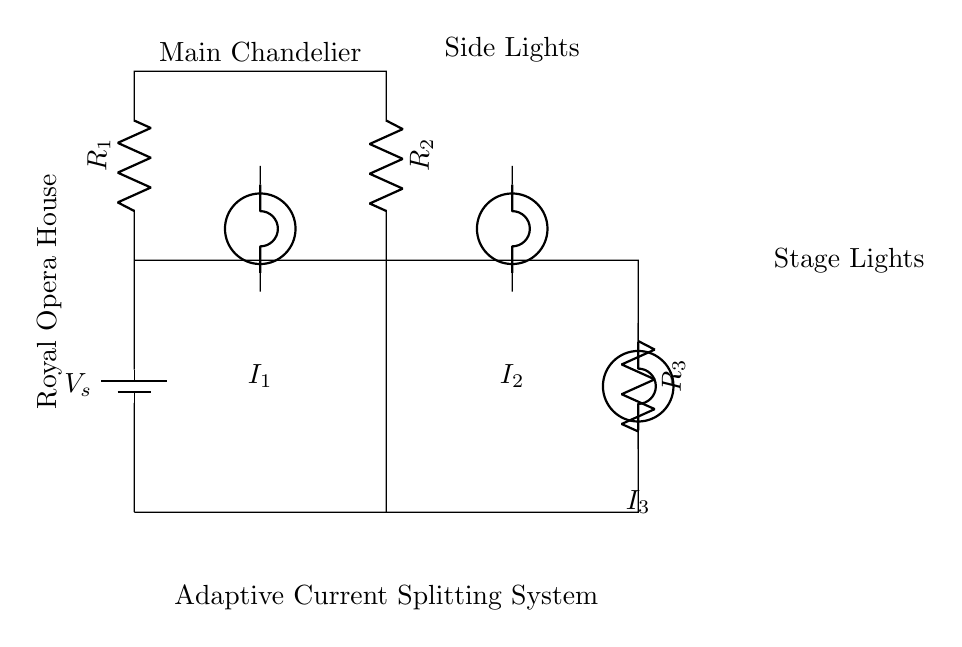What components are present in the circuit? The circuit includes a battery, three resistors, and three bulbs. The battery provides power, while the resistors and bulbs are part of the adaptive current splitting system.
Answer: Battery, resistors, bulbs What is the purpose of the adaptive current splitting system? The system is designed to control the brightness of different lights in the Royal Opera House, allowing for illumination adjustments depending on the performance requirements.
Answer: Dimming lights How many branches does the circuit have? The circuit has three branches, corresponding to the three resistors and the lights connected to them. Each branch receives a portion of the total current.
Answer: Three branches What is the current through the side lights branch? The current through the side lights branch is represented by I2. Since the circuit is a current divider, this value will depend on the relative resistance of R2 compared to R1 and R3.
Answer: I2 Which light is associated with the main chandelier? The bulb connected to the branch with resistor R1 is the main chandelier. It is also labeled in the diagram to indicate its importance in the overall lighting design.
Answer: Main Chandelier If R1 is greater than R2, which branch will have the highest current? If R1 is greater than R2, then R2 will have the highest current. This is due to the principles of a current divider, where less resistance allows for more current flow.
Answer: Side Lights What does the notation I1 signify in the circuit? The notation I1 signifies the current flowing through the branch connected to the main chandelier, which is determined by the resistances present in the circuit.
Answer: Current through Main Chandelier 